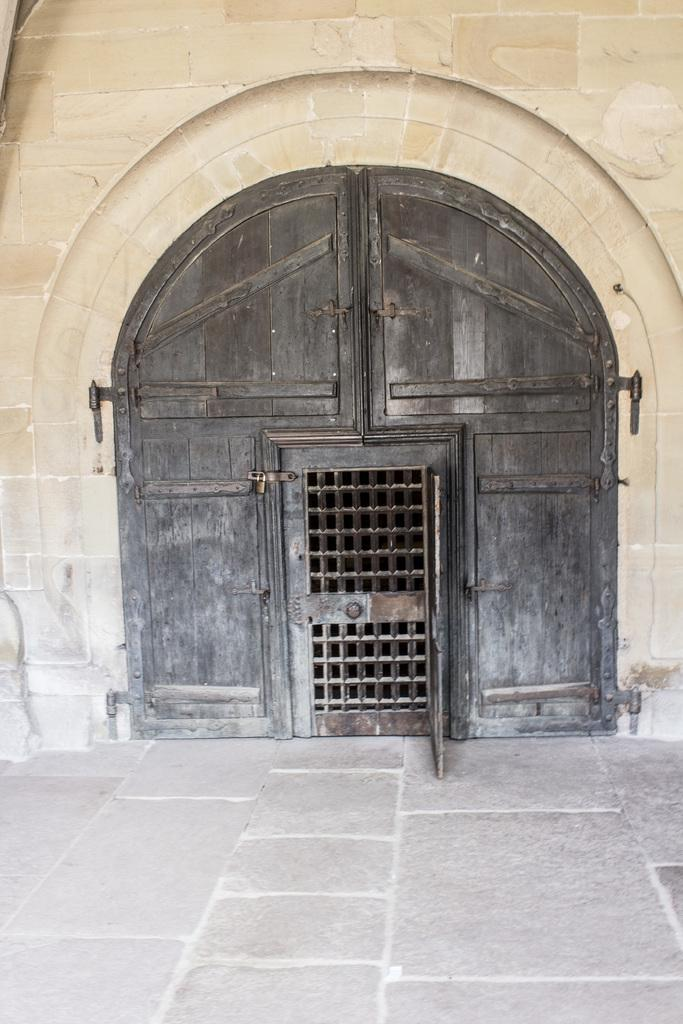What type of structure is present in the image? There is a wall in the image. What is the main feature of the wall? There is a wooden door in the wall. What is visible at the bottom of the image? There is a floor visible at the bottom of the image. What type of hill can be seen in the background of the image? There is no hill visible in the image; it only features a wall, a wooden door, and a floor. 